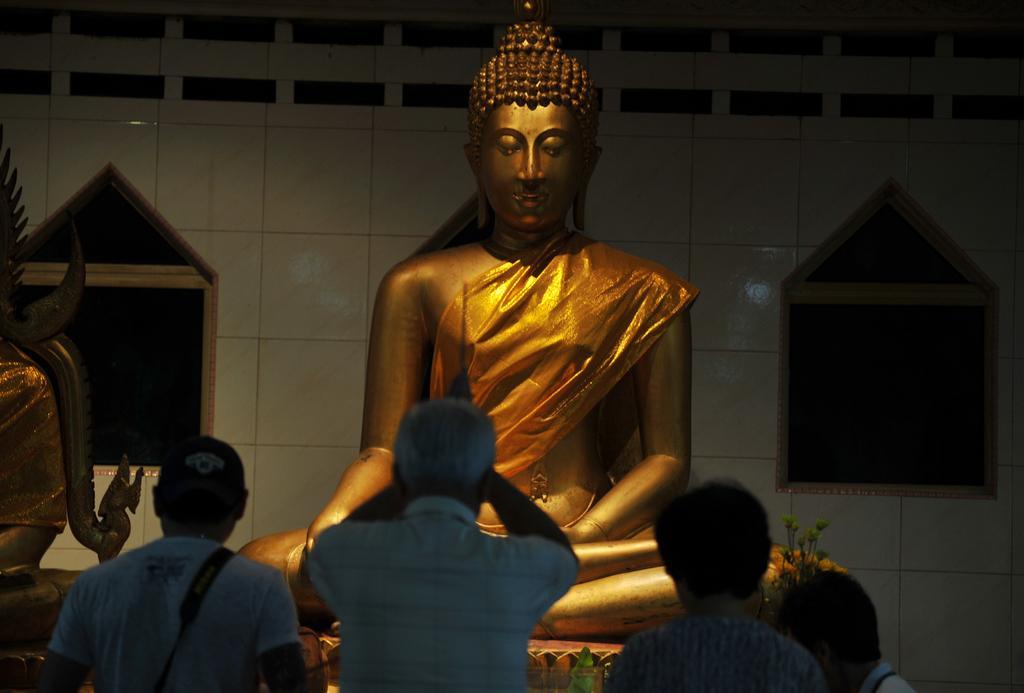How would you summarize this image in a sentence or two? In this image, we can see statues. At the bottom, there are few people. Background we can see tile wall. Here we can see flowers and few objects. 